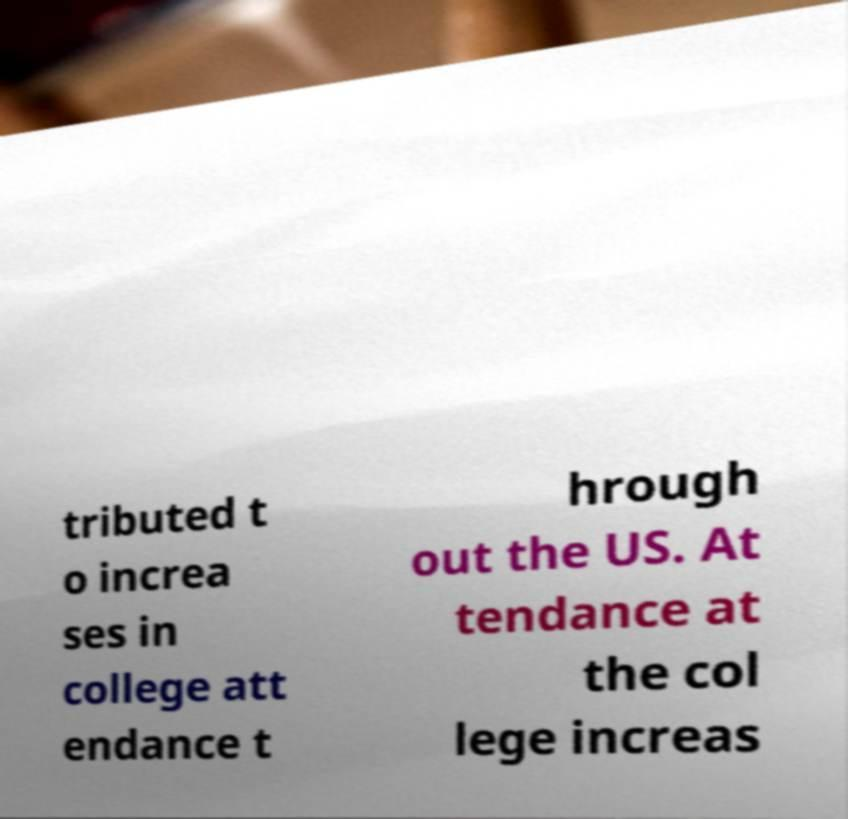Please identify and transcribe the text found in this image. tributed t o increa ses in college att endance t hrough out the US. At tendance at the col lege increas 